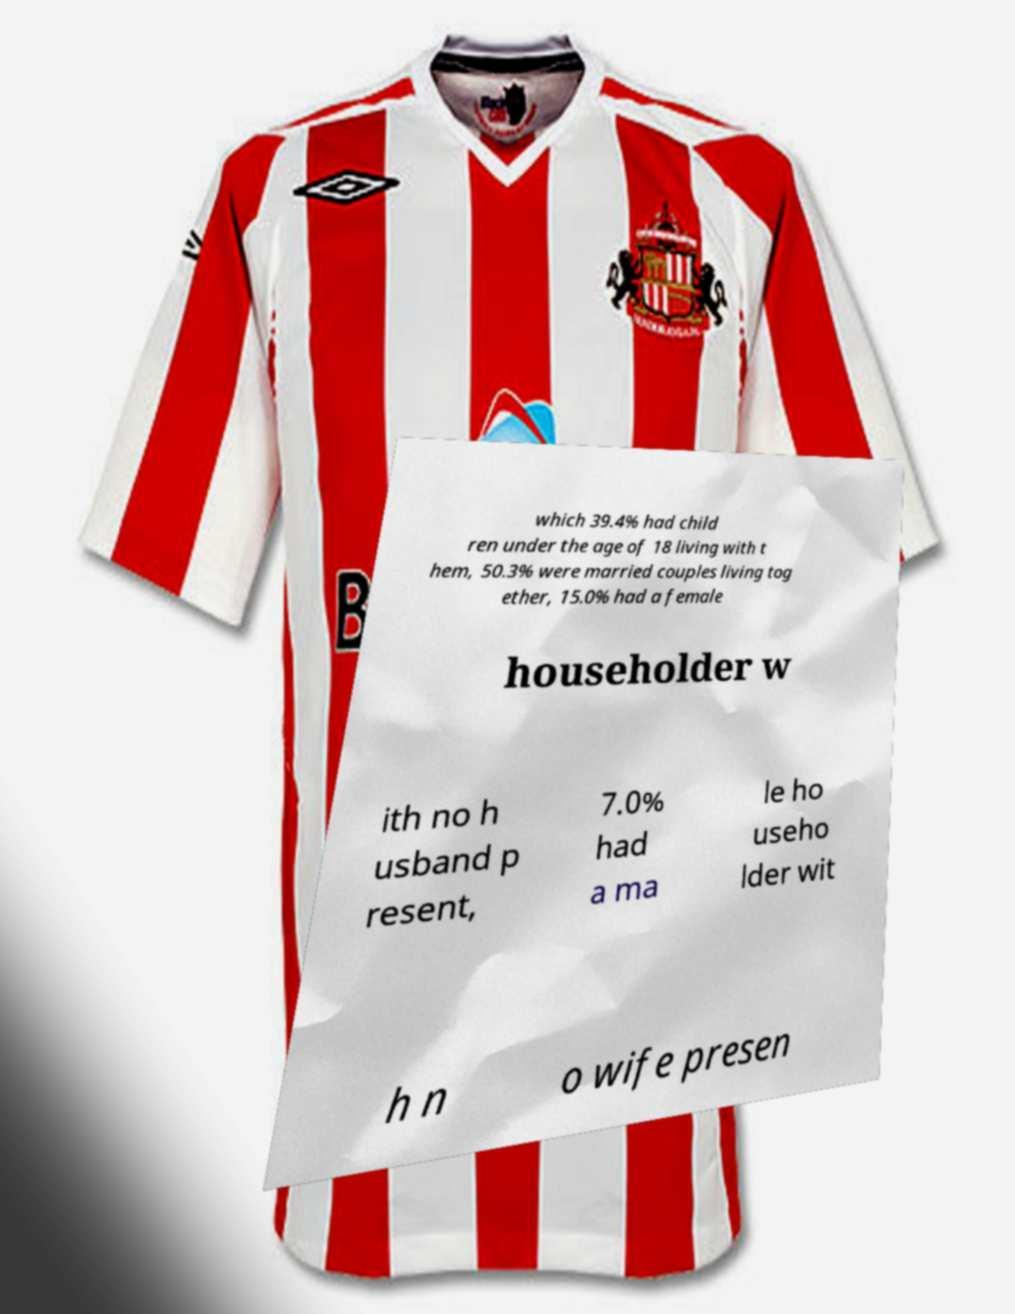Could you assist in decoding the text presented in this image and type it out clearly? which 39.4% had child ren under the age of 18 living with t hem, 50.3% were married couples living tog ether, 15.0% had a female householder w ith no h usband p resent, 7.0% had a ma le ho useho lder wit h n o wife presen 